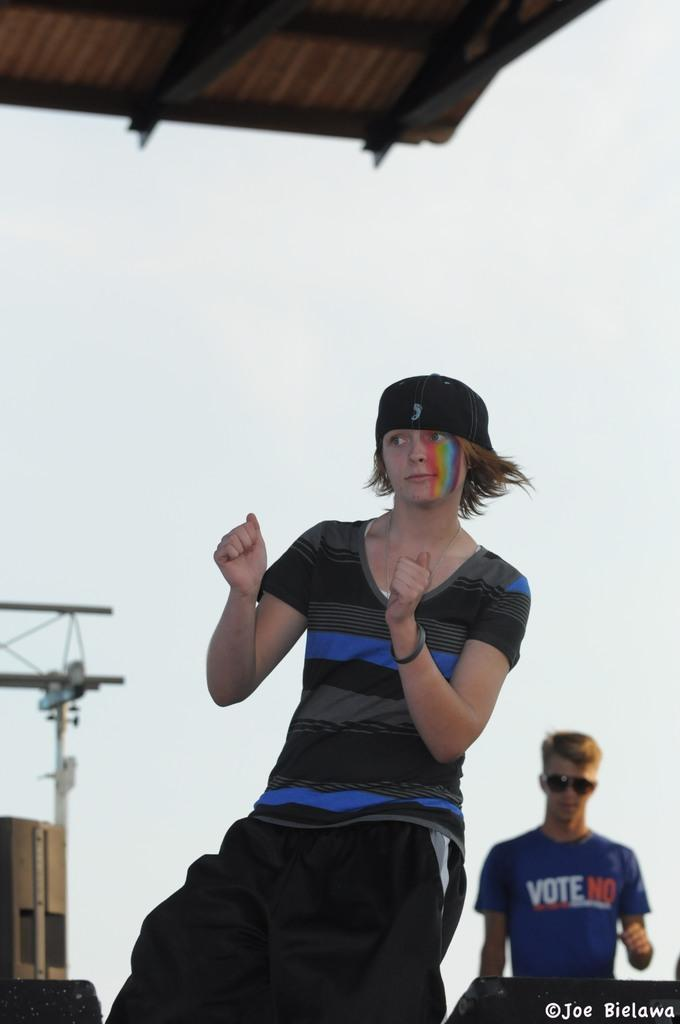<image>
Describe the image concisely. A girl is dancing on a stage in front of a boy with a shirt that says Vote No. 